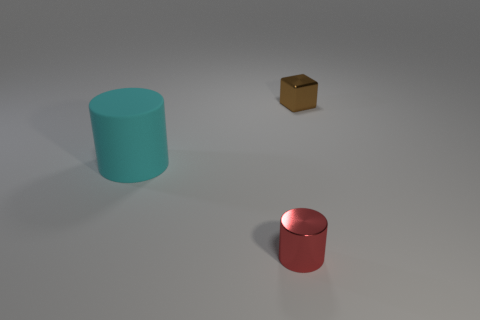Is the number of brown shiny cubes that are on the left side of the matte cylinder less than the number of small cyan objects?
Offer a terse response. No. There is a thing that is right of the cyan rubber cylinder and left of the tiny metallic cube; what is its color?
Your answer should be compact. Red. How many other things are the same shape as the brown metallic thing?
Provide a short and direct response. 0. Is the number of red shiny cylinders left of the matte cylinder less than the number of tiny things in front of the brown metal object?
Make the answer very short. Yes. Do the red cylinder and the big thing that is in front of the brown metal object have the same material?
Offer a terse response. No. Is there any other thing that is made of the same material as the big cyan thing?
Provide a succinct answer. No. Is the number of tiny things greater than the number of tiny metallic cubes?
Give a very brief answer. Yes. What shape is the small object that is in front of the thing on the left side of the metallic object on the left side of the small metal cube?
Your answer should be compact. Cylinder. Are the tiny cube that is on the right side of the small red object and the thing in front of the cyan thing made of the same material?
Provide a short and direct response. Yes. What is the shape of the red object that is the same material as the small block?
Keep it short and to the point. Cylinder. 